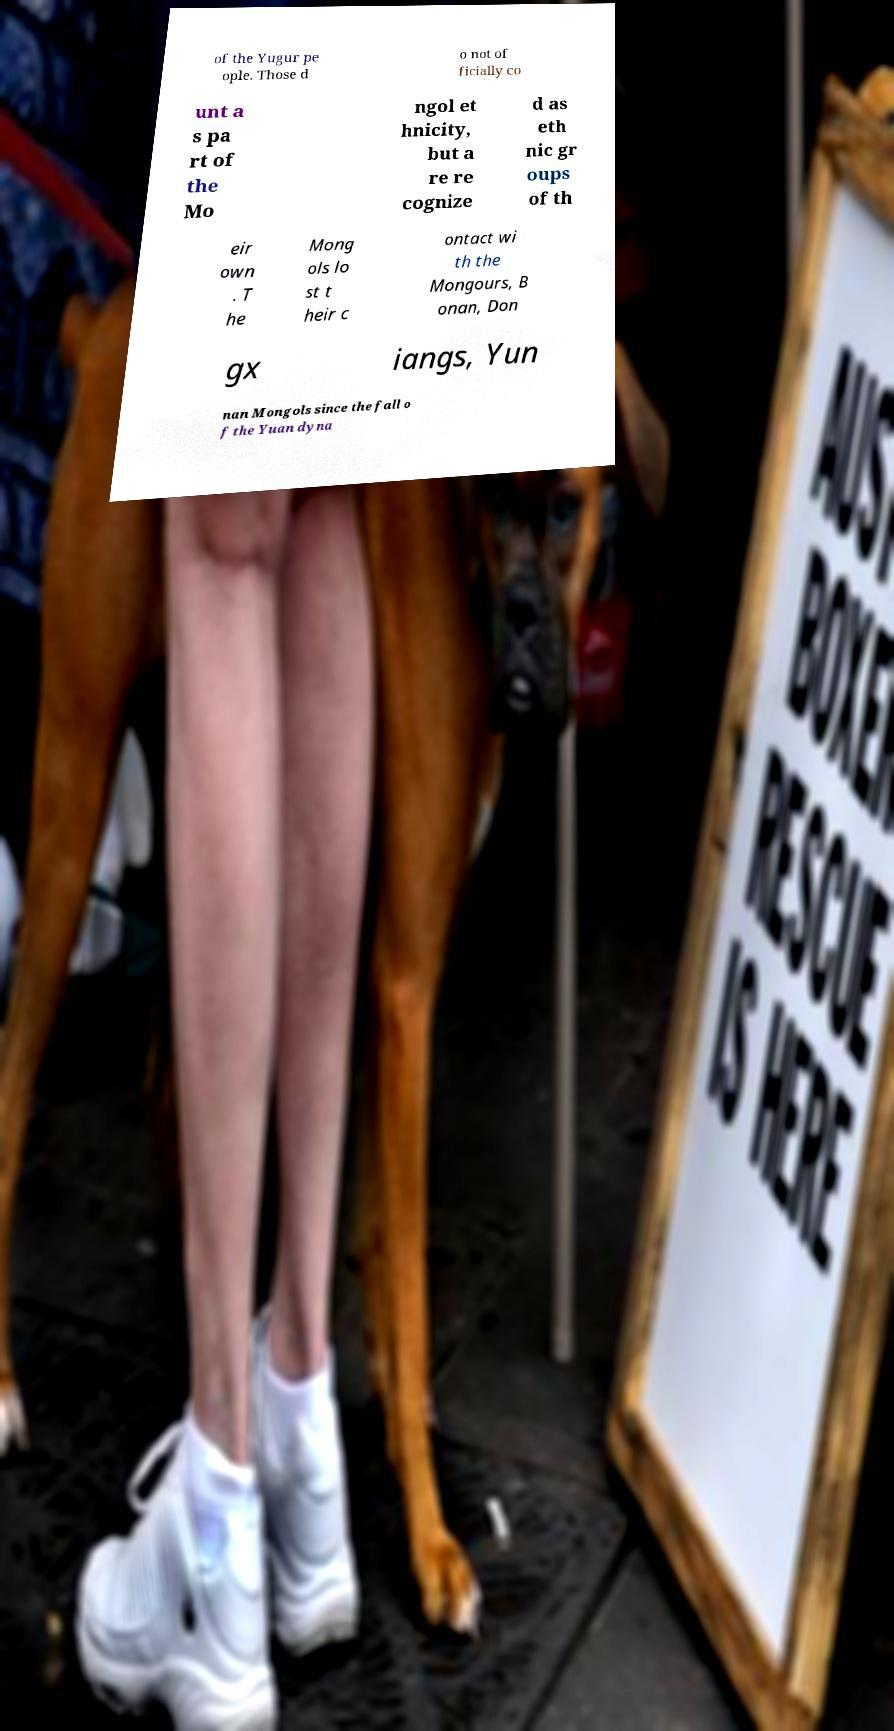Can you accurately transcribe the text from the provided image for me? of the Yugur pe ople. Those d o not of ficially co unt a s pa rt of the Mo ngol et hnicity, but a re re cognize d as eth nic gr oups of th eir own . T he Mong ols lo st t heir c ontact wi th the Mongours, B onan, Don gx iangs, Yun nan Mongols since the fall o f the Yuan dyna 